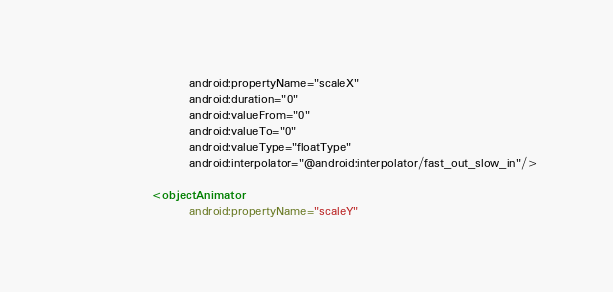Convert code to text. <code><loc_0><loc_0><loc_500><loc_500><_XML_>                        android:propertyName="scaleX"
                        android:duration="0"
                        android:valueFrom="0"
                        android:valueTo="0"
                        android:valueType="floatType"
                        android:interpolator="@android:interpolator/fast_out_slow_in"/>

                <objectAnimator
                        android:propertyName="scaleY"</code> 